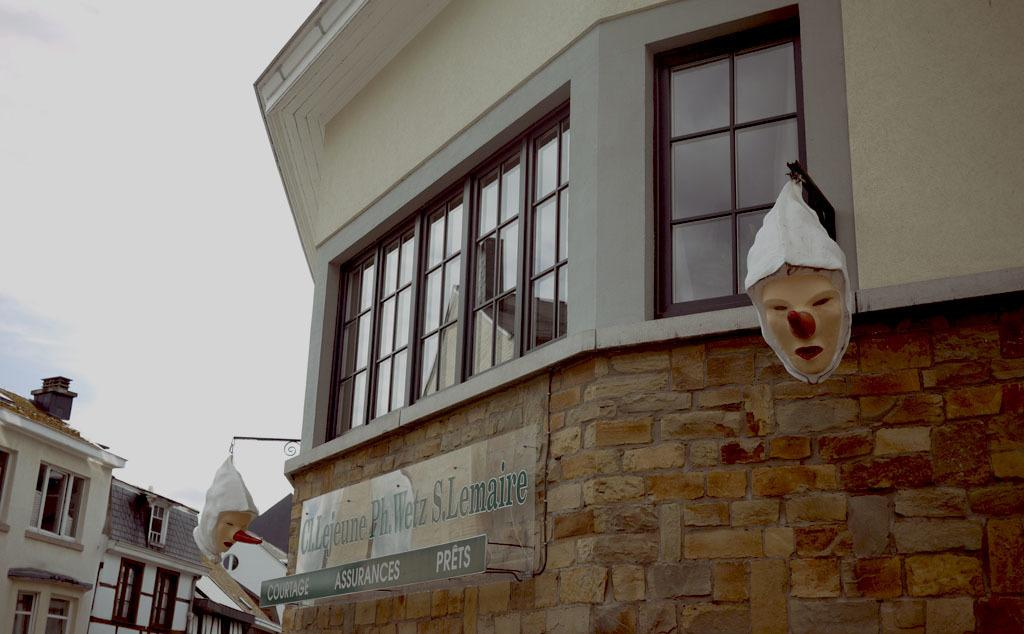What type of structures can be seen in the image? There are buildings in the image. Are there any specific features on one of the buildings? Yes, there are two masks on one of the buildings. Is there any text present on the building with the masks? Yes, there is text written on the building with the masks. What can be seen in the background of the image? The sky is visible in the background of the image. How many people are standing in a line holding sticks in the image? There are no people, lines, or sticks present in the image. 